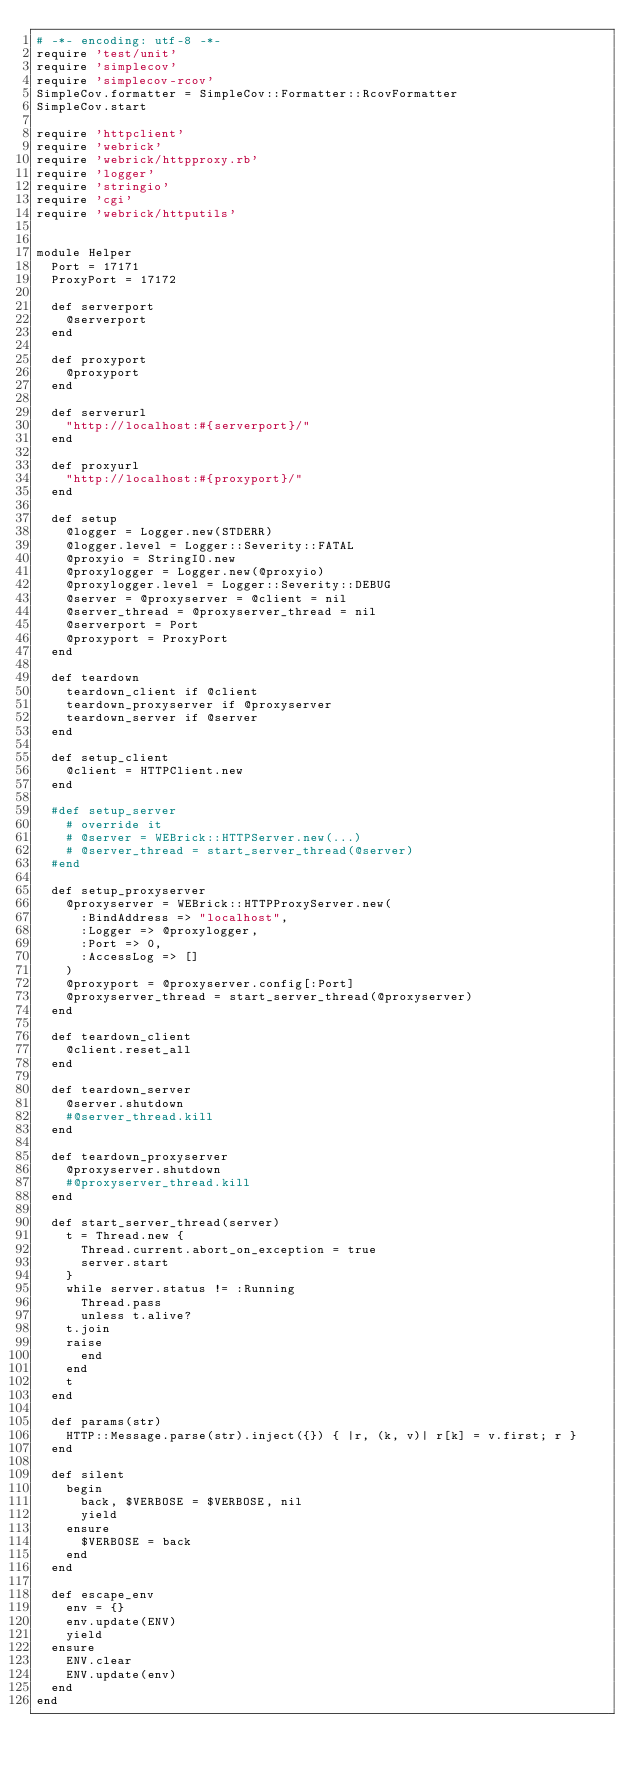<code> <loc_0><loc_0><loc_500><loc_500><_Ruby_># -*- encoding: utf-8 -*-
require 'test/unit'
require 'simplecov'
require 'simplecov-rcov'
SimpleCov.formatter = SimpleCov::Formatter::RcovFormatter
SimpleCov.start

require 'httpclient'
require 'webrick'
require 'webrick/httpproxy.rb'
require 'logger'
require 'stringio'
require 'cgi'
require 'webrick/httputils'


module Helper
  Port = 17171
  ProxyPort = 17172

  def serverport
    @serverport
  end

  def proxyport
    @proxyport
  end

  def serverurl
    "http://localhost:#{serverport}/"
  end

  def proxyurl
    "http://localhost:#{proxyport}/"
  end

  def setup
    @logger = Logger.new(STDERR)
    @logger.level = Logger::Severity::FATAL
    @proxyio = StringIO.new
    @proxylogger = Logger.new(@proxyio)
    @proxylogger.level = Logger::Severity::DEBUG
    @server = @proxyserver = @client = nil
    @server_thread = @proxyserver_thread = nil
    @serverport = Port
    @proxyport = ProxyPort
  end

  def teardown
    teardown_client if @client
    teardown_proxyserver if @proxyserver
    teardown_server if @server
  end

  def setup_client
    @client = HTTPClient.new
  end

  #def setup_server
    # override it
    # @server = WEBrick::HTTPServer.new(...)
    # @server_thread = start_server_thread(@server)
  #end

  def setup_proxyserver
    @proxyserver = WEBrick::HTTPProxyServer.new(
      :BindAddress => "localhost",
      :Logger => @proxylogger,
      :Port => 0,
      :AccessLog => []
    )
    @proxyport = @proxyserver.config[:Port]
    @proxyserver_thread = start_server_thread(@proxyserver)
  end

  def teardown_client
    @client.reset_all
  end

  def teardown_server
    @server.shutdown
    #@server_thread.kill
  end

  def teardown_proxyserver
    @proxyserver.shutdown
    #@proxyserver_thread.kill
  end

  def start_server_thread(server)
    t = Thread.new {
      Thread.current.abort_on_exception = true
      server.start
    }
    while server.status != :Running
      Thread.pass
      unless t.alive?
	t.join
	raise
      end
    end
    t
  end

  def params(str)
    HTTP::Message.parse(str).inject({}) { |r, (k, v)| r[k] = v.first; r }
  end

  def silent
    begin
      back, $VERBOSE = $VERBOSE, nil
      yield
    ensure
      $VERBOSE = back
    end
  end

  def escape_env
    env = {}
    env.update(ENV)
    yield
  ensure
    ENV.clear
    ENV.update(env)
  end
end
</code> 